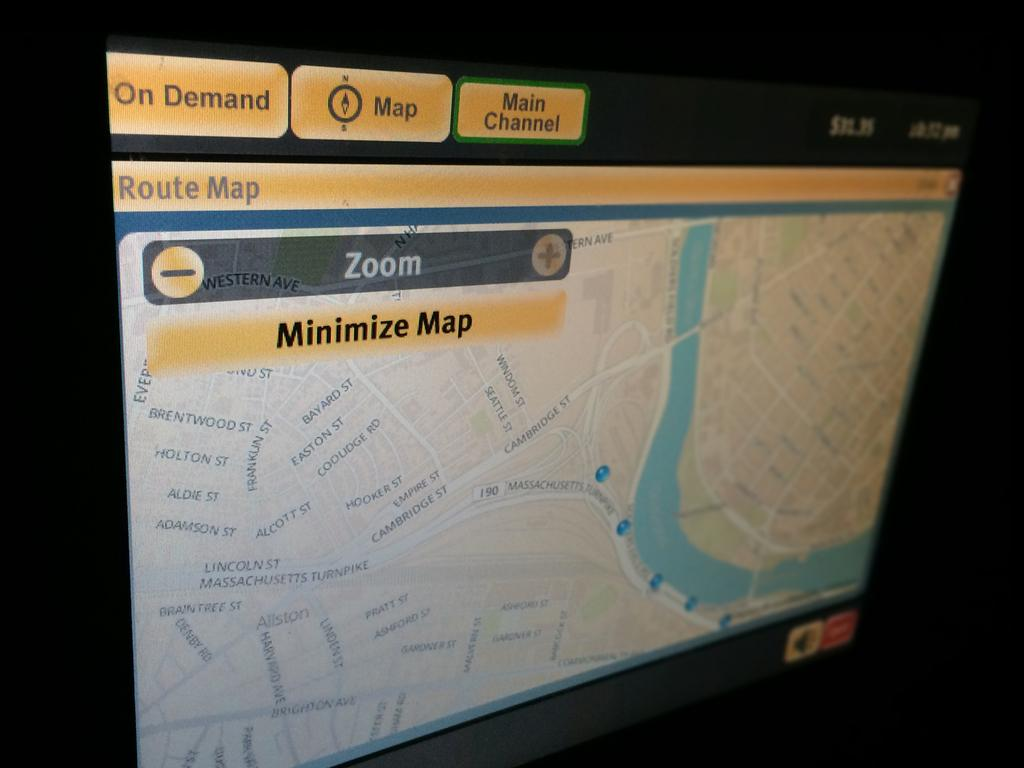Provide a one-sentence caption for the provided image. A screen showing a map that gives the option to minimise the map. 